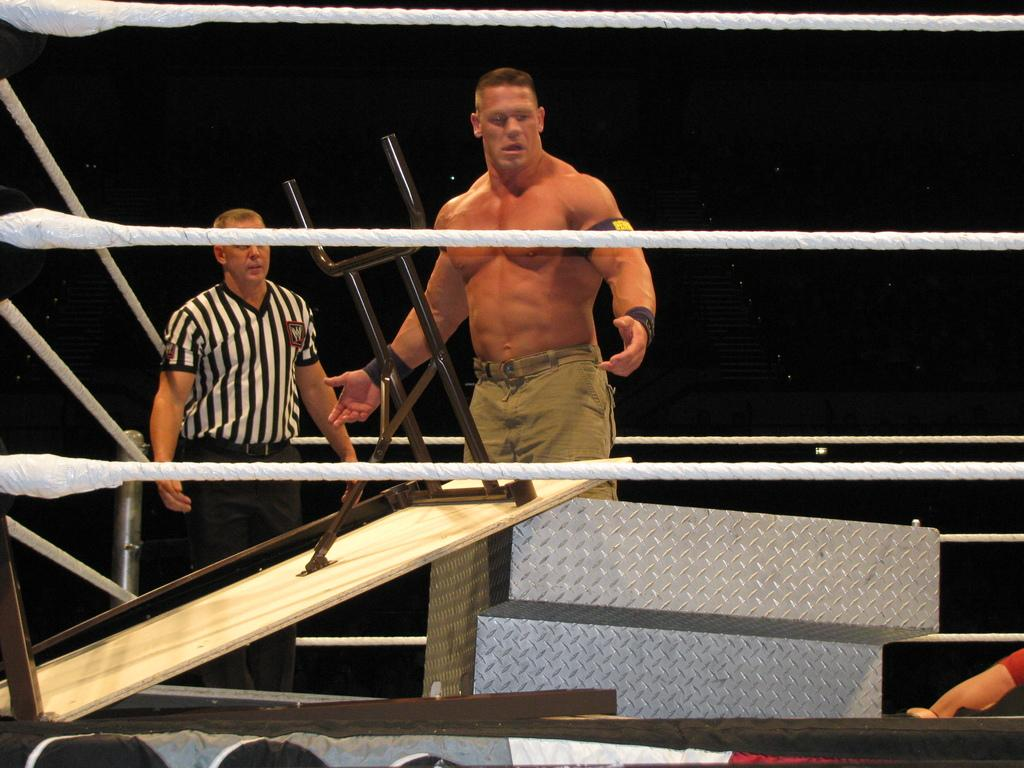What type of location is depicted in the image? There is a boxing court in the image. Are there any objects or furniture in the boxing court? Yes, there is a table in the boxing court. What architectural feature can be seen in the boxing court? There are stairs in the boxing court. How many people are present in the boxing court? There are three people in the boxing court. What is the lighting condition in the image? The background of the image is dark. What type of swing can be seen in the background of the image? There is no swing present in the image; it features a boxing court with a table, stairs, and three people. What kind of attraction is taking place in the boxing court? The image does not depict any attraction; it simply shows a boxing court with people and furniture. 